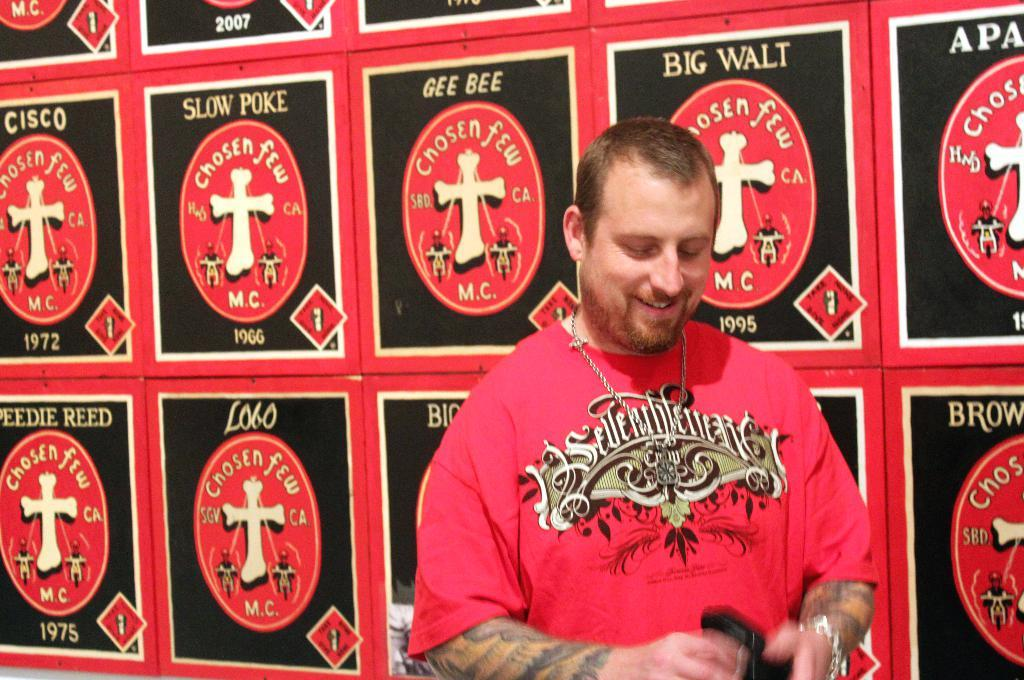What is the main subject of the image? There is a person in the image. What can be seen in the background of the image? There are posters in the background of the image. What type of skin condition does the person's grandmother have in the image? There is no mention of a grandmother or any skin condition in the image. 